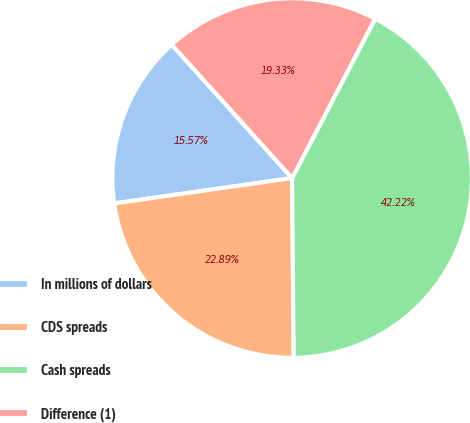<chart> <loc_0><loc_0><loc_500><loc_500><pie_chart><fcel>In millions of dollars<fcel>CDS spreads<fcel>Cash spreads<fcel>Difference (1)<nl><fcel>15.57%<fcel>22.89%<fcel>42.22%<fcel>19.33%<nl></chart> 